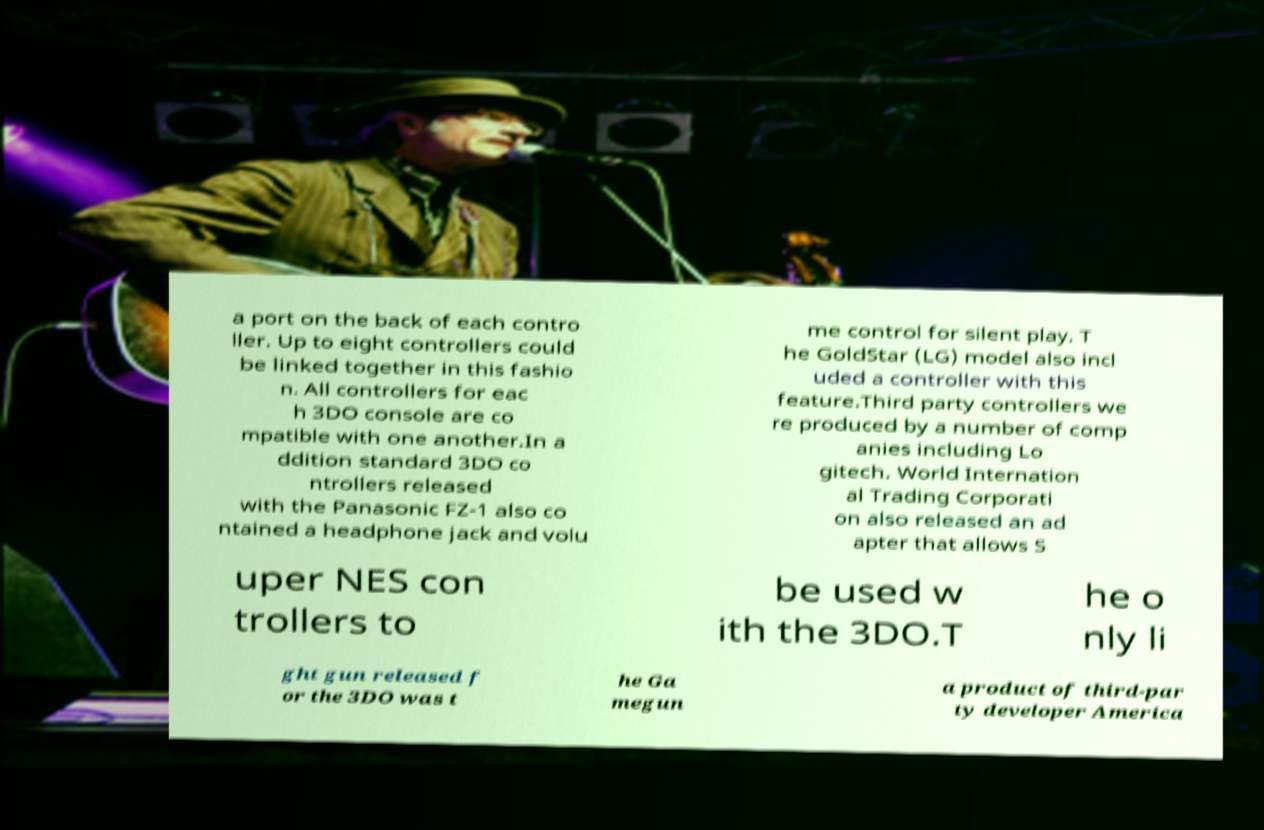For documentation purposes, I need the text within this image transcribed. Could you provide that? a port on the back of each contro ller. Up to eight controllers could be linked together in this fashio n. All controllers for eac h 3DO console are co mpatible with one another.In a ddition standard 3DO co ntrollers released with the Panasonic FZ-1 also co ntained a headphone jack and volu me control for silent play. T he GoldStar (LG) model also incl uded a controller with this feature.Third party controllers we re produced by a number of comp anies including Lo gitech. World Internation al Trading Corporati on also released an ad apter that allows S uper NES con trollers to be used w ith the 3DO.T he o nly li ght gun released f or the 3DO was t he Ga megun a product of third-par ty developer America 